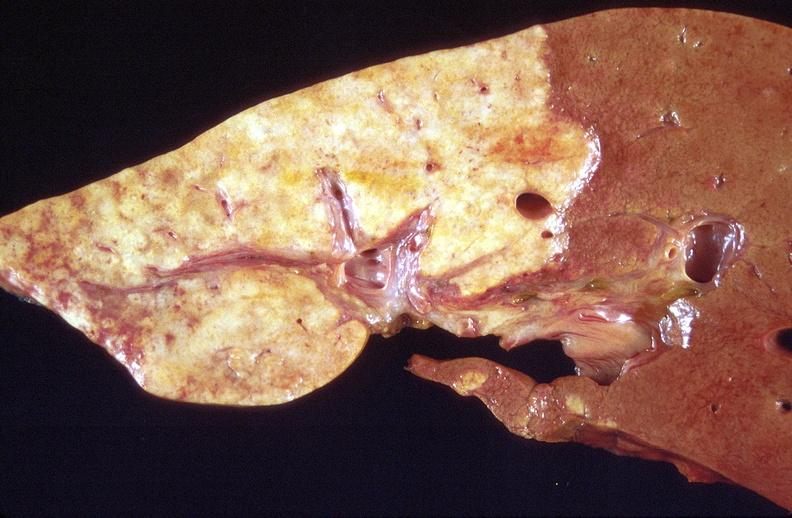s peritoneum present?
Answer the question using a single word or phrase. No 